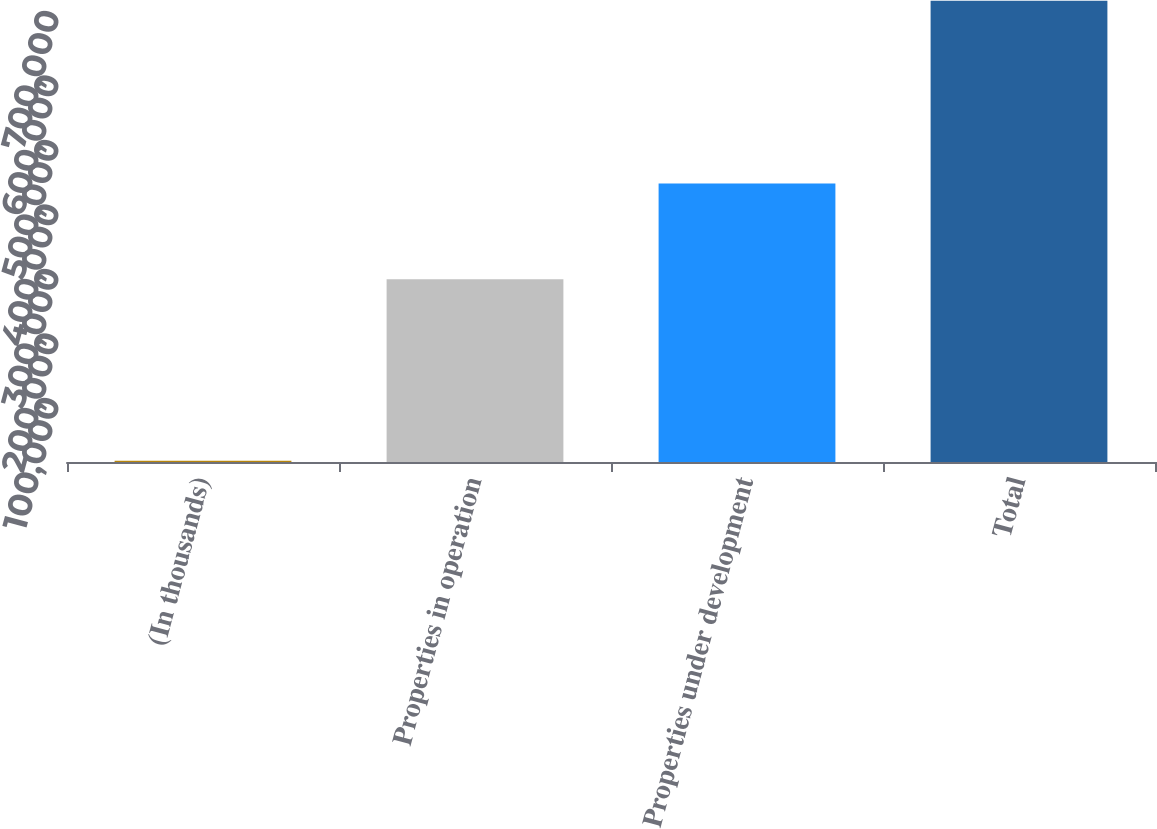<chart> <loc_0><loc_0><loc_500><loc_500><bar_chart><fcel>(In thousands)<fcel>Properties in operation<fcel>Properties under development<fcel>Total<nl><fcel>2013<fcel>283393<fcel>431849<fcel>715242<nl></chart> 